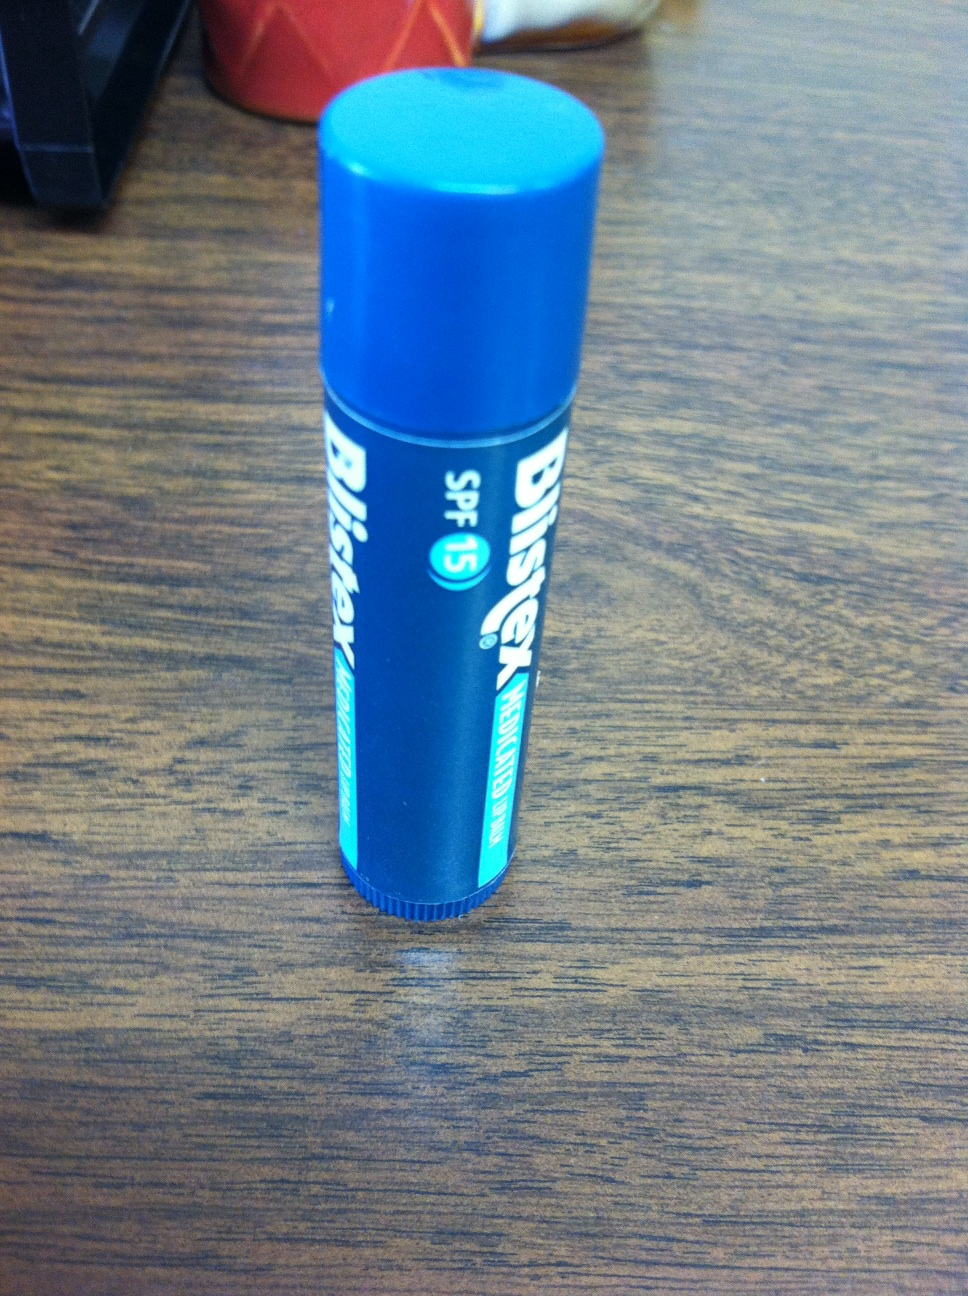What are the benefits of using this specific chapstick? The chapstick in the image, Blistex Medicated Balm with SPF 15, offers several benefits. Firstly, it provides sun protection with its SPF 15, shielding your lips from ultraviolet (UV) damage. It's also formulated with medicated ingredients to soothe and heal chapped or dry lips, offering immediate relief and long-term hydration. Additionally, its compact size makes it portable and convenient for everyday use. Can you tell me more about how SPF 15 protects my lips? Certainly! SPF 15 in chapstick works by blocking about 93% of the sun's UVB rays, which are the primary cause of sunburn. UVB rays can also contribute to skin cancer and premature aging. By using a chapstick with SPF 15, you help prevent these harmful effects on your lips, keeping them healthier and more resilient. It's particularly useful during outdoor activities where sun exposure is higher, such as hiking, swimming, or simply being out in the sun for extended periods. 